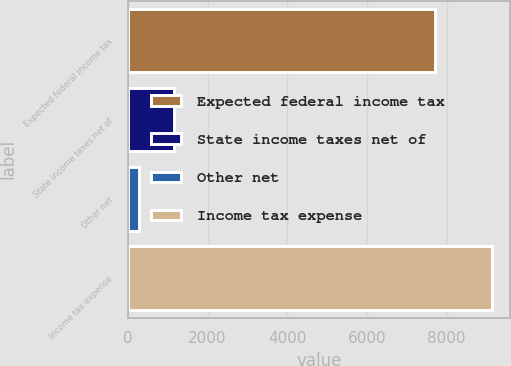<chart> <loc_0><loc_0><loc_500><loc_500><bar_chart><fcel>Expected federal income tax<fcel>State income taxes net of<fcel>Other net<fcel>Income tax expense<nl><fcel>7709<fcel>1166<fcel>281<fcel>9131<nl></chart> 